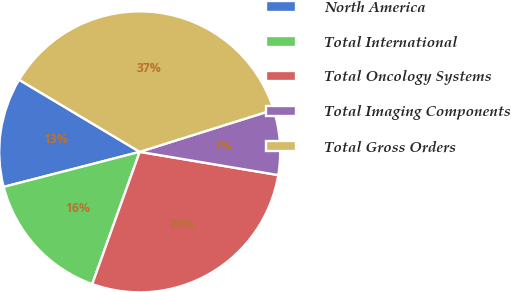<chart> <loc_0><loc_0><loc_500><loc_500><pie_chart><fcel>North America<fcel>Total International<fcel>Total Oncology Systems<fcel>Total Imaging Components<fcel>Total Gross Orders<nl><fcel>12.59%<fcel>15.5%<fcel>27.84%<fcel>7.49%<fcel>36.58%<nl></chart> 